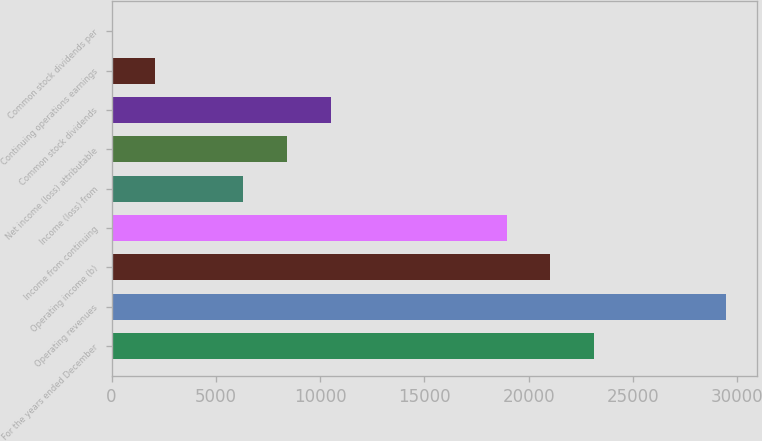Convert chart. <chart><loc_0><loc_0><loc_500><loc_500><bar_chart><fcel>For the years ended December<fcel>Operating revenues<fcel>Operating income (b)<fcel>Income from continuing<fcel>Income (loss) from<fcel>Net income (loss) attributable<fcel>Common stock dividends<fcel>Continuing operations earnings<fcel>Common stock dividends per<nl><fcel>23146<fcel>29458.2<fcel>21042<fcel>18938<fcel>6313.72<fcel>8417.76<fcel>10521.8<fcel>2105.64<fcel>1.6<nl></chart> 